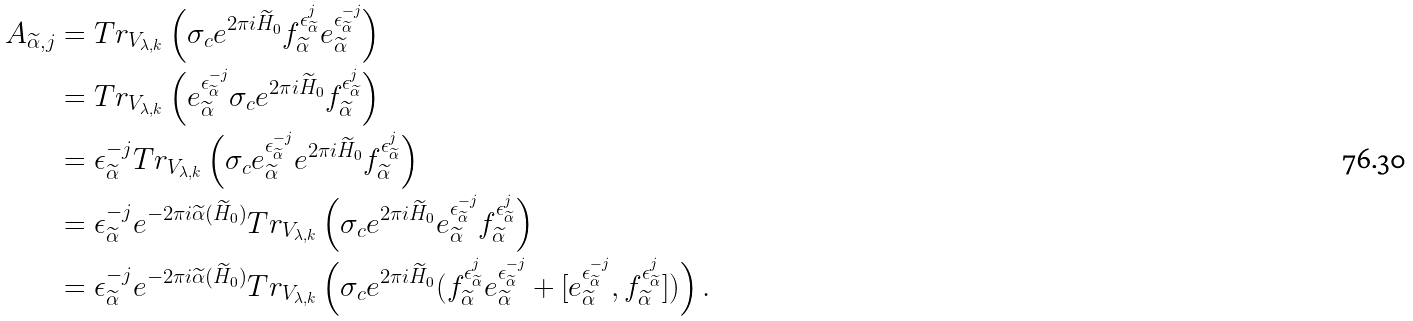<formula> <loc_0><loc_0><loc_500><loc_500>A _ { \widetilde { \alpha } , j } & = T r _ { V _ { \lambda , k } } \left ( \sigma _ { c } e ^ { 2 \pi i \widetilde { H } _ { 0 } } f _ { \widetilde { \alpha } } ^ { \epsilon ^ { j } _ { \widetilde { \alpha } } } e _ { \widetilde { \alpha } } ^ { \epsilon ^ { - j } _ { \widetilde { \alpha } } } \right ) \\ & = T r _ { V _ { \lambda , k } } \left ( e _ { \widetilde { \alpha } } ^ { \epsilon ^ { - j } _ { \widetilde { \alpha } } } \sigma _ { c } e ^ { 2 \pi i \widetilde { H } _ { 0 } } f _ { \widetilde { \alpha } } ^ { \epsilon ^ { j } _ { \widetilde { \alpha } } } \right ) \\ & = \epsilon _ { \widetilde { \alpha } } ^ { - j } T r _ { V _ { \lambda , k } } \left ( \sigma _ { c } e _ { \widetilde { \alpha } } ^ { \epsilon ^ { - j } _ { \widetilde { \alpha } } } e ^ { 2 \pi i \widetilde { H } _ { 0 } } f _ { \widetilde { \alpha } } ^ { \epsilon ^ { j } _ { \widetilde { \alpha } } } \right ) \\ & = \epsilon _ { \widetilde { \alpha } } ^ { - j } e ^ { - 2 \pi i \widetilde { \alpha } ( \widetilde { H } _ { 0 } ) } T r _ { V _ { \lambda , k } } \left ( \sigma _ { c } e ^ { 2 \pi i \widetilde { H } _ { 0 } } e _ { \widetilde { \alpha } } ^ { \epsilon ^ { - j } _ { \widetilde { \alpha } } } f _ { \widetilde { \alpha } } ^ { \epsilon ^ { j } _ { \widetilde { \alpha } } } \right ) \\ & = \epsilon _ { \widetilde { \alpha } } ^ { - j } e ^ { - 2 \pi i \widetilde { \alpha } ( \widetilde { H } _ { 0 } ) } T r _ { V _ { \lambda , k } } \left ( \sigma _ { c } e ^ { 2 \pi i \widetilde { H } _ { 0 } } ( f _ { \widetilde { \alpha } } ^ { \epsilon ^ { j } _ { \widetilde { \alpha } } } e _ { \widetilde { \alpha } } ^ { \epsilon ^ { - j } _ { \widetilde { \alpha } } } + [ e _ { \widetilde { \alpha } } ^ { \epsilon ^ { - j } _ { \widetilde { \alpha } } } , f _ { \widetilde { \alpha } } ^ { \epsilon ^ { j } _ { \widetilde { \alpha } } } ] ) \right ) .</formula> 